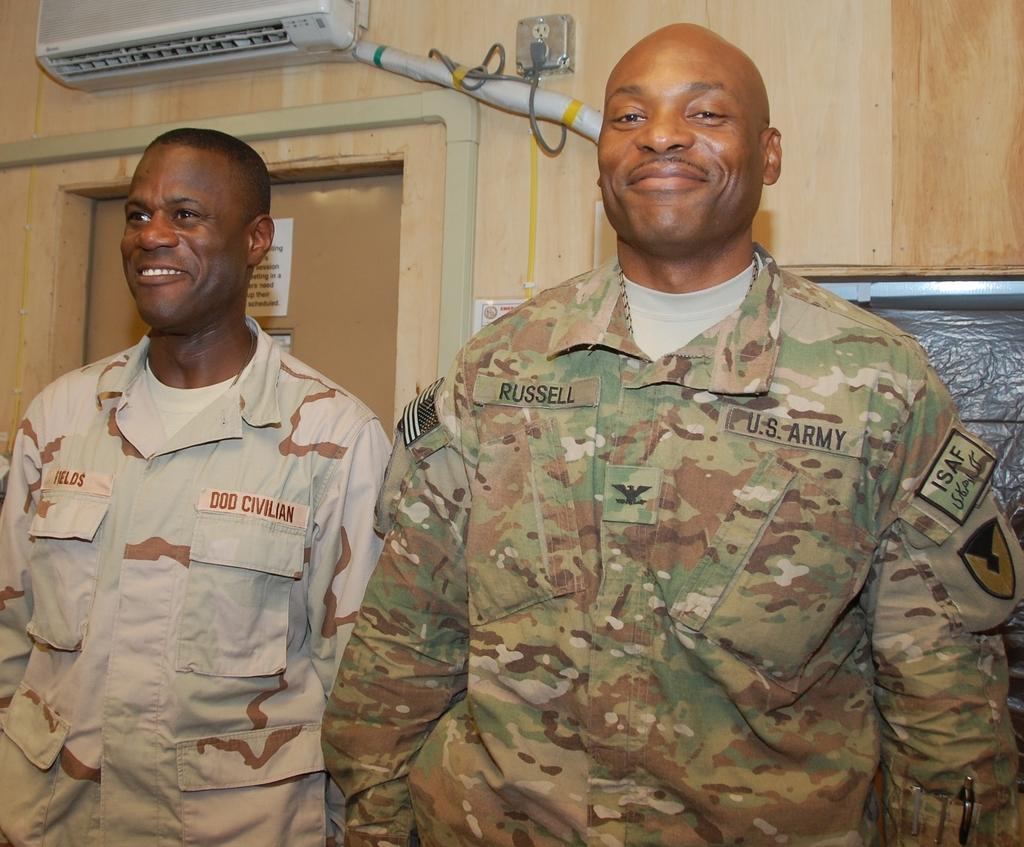Describe this image in one or two sentences. Here a man is standing, he wore army dress and also smiling. On the left side another man is there behind him there is a door. 